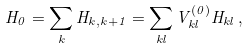<formula> <loc_0><loc_0><loc_500><loc_500>H _ { 0 } = \sum _ { k } H _ { k , k + 1 } = \sum _ { k l } V ^ { ( 0 ) } _ { k l } H _ { k l } \, ,</formula> 